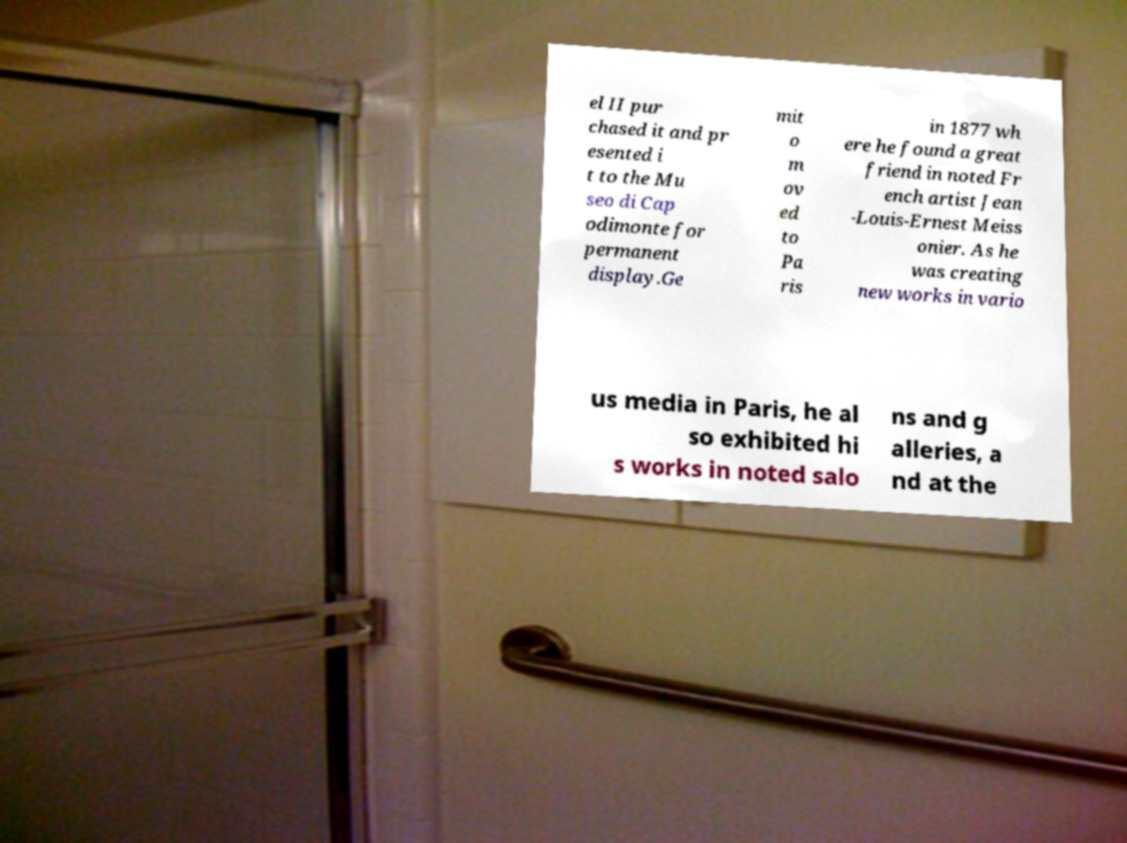Please identify and transcribe the text found in this image. el II pur chased it and pr esented i t to the Mu seo di Cap odimonte for permanent display.Ge mit o m ov ed to Pa ris in 1877 wh ere he found a great friend in noted Fr ench artist Jean -Louis-Ernest Meiss onier. As he was creating new works in vario us media in Paris, he al so exhibited hi s works in noted salo ns and g alleries, a nd at the 